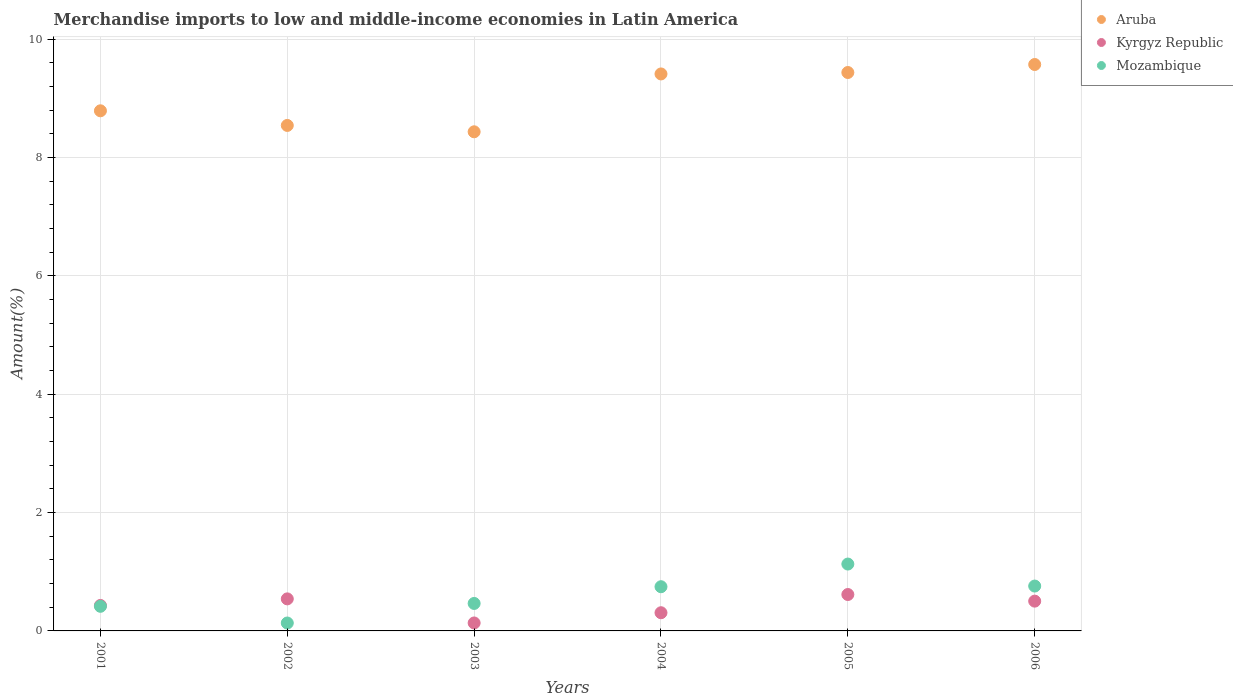How many different coloured dotlines are there?
Offer a terse response. 3. Is the number of dotlines equal to the number of legend labels?
Keep it short and to the point. Yes. What is the percentage of amount earned from merchandise imports in Kyrgyz Republic in 2004?
Your answer should be very brief. 0.31. Across all years, what is the maximum percentage of amount earned from merchandise imports in Aruba?
Offer a very short reply. 9.57. Across all years, what is the minimum percentage of amount earned from merchandise imports in Kyrgyz Republic?
Provide a short and direct response. 0.13. In which year was the percentage of amount earned from merchandise imports in Kyrgyz Republic maximum?
Your response must be concise. 2005. What is the total percentage of amount earned from merchandise imports in Kyrgyz Republic in the graph?
Keep it short and to the point. 2.53. What is the difference between the percentage of amount earned from merchandise imports in Kyrgyz Republic in 2002 and that in 2006?
Keep it short and to the point. 0.04. What is the difference between the percentage of amount earned from merchandise imports in Mozambique in 2003 and the percentage of amount earned from merchandise imports in Aruba in 2005?
Your response must be concise. -8.97. What is the average percentage of amount earned from merchandise imports in Kyrgyz Republic per year?
Your answer should be very brief. 0.42. In the year 2004, what is the difference between the percentage of amount earned from merchandise imports in Mozambique and percentage of amount earned from merchandise imports in Aruba?
Your answer should be very brief. -8.67. What is the ratio of the percentage of amount earned from merchandise imports in Aruba in 2005 to that in 2006?
Your answer should be compact. 0.99. Is the percentage of amount earned from merchandise imports in Kyrgyz Republic in 2001 less than that in 2006?
Ensure brevity in your answer.  Yes. Is the difference between the percentage of amount earned from merchandise imports in Mozambique in 2004 and 2006 greater than the difference between the percentage of amount earned from merchandise imports in Aruba in 2004 and 2006?
Your answer should be very brief. Yes. What is the difference between the highest and the second highest percentage of amount earned from merchandise imports in Mozambique?
Offer a very short reply. 0.37. What is the difference between the highest and the lowest percentage of amount earned from merchandise imports in Mozambique?
Provide a short and direct response. 1. In how many years, is the percentage of amount earned from merchandise imports in Mozambique greater than the average percentage of amount earned from merchandise imports in Mozambique taken over all years?
Give a very brief answer. 3. Is the sum of the percentage of amount earned from merchandise imports in Mozambique in 2001 and 2002 greater than the maximum percentage of amount earned from merchandise imports in Aruba across all years?
Provide a short and direct response. No. Is it the case that in every year, the sum of the percentage of amount earned from merchandise imports in Kyrgyz Republic and percentage of amount earned from merchandise imports in Mozambique  is greater than the percentage of amount earned from merchandise imports in Aruba?
Your answer should be compact. No. Does the percentage of amount earned from merchandise imports in Aruba monotonically increase over the years?
Provide a succinct answer. No. Is the percentage of amount earned from merchandise imports in Kyrgyz Republic strictly less than the percentage of amount earned from merchandise imports in Aruba over the years?
Ensure brevity in your answer.  Yes. How many years are there in the graph?
Make the answer very short. 6. Are the values on the major ticks of Y-axis written in scientific E-notation?
Your answer should be very brief. No. Does the graph contain any zero values?
Provide a succinct answer. No. Does the graph contain grids?
Your answer should be very brief. Yes. Where does the legend appear in the graph?
Your response must be concise. Top right. How are the legend labels stacked?
Offer a very short reply. Vertical. What is the title of the graph?
Offer a very short reply. Merchandise imports to low and middle-income economies in Latin America. What is the label or title of the Y-axis?
Provide a short and direct response. Amount(%). What is the Amount(%) in Aruba in 2001?
Provide a short and direct response. 8.79. What is the Amount(%) of Kyrgyz Republic in 2001?
Give a very brief answer. 0.43. What is the Amount(%) of Mozambique in 2001?
Your response must be concise. 0.42. What is the Amount(%) in Aruba in 2002?
Provide a succinct answer. 8.54. What is the Amount(%) of Kyrgyz Republic in 2002?
Ensure brevity in your answer.  0.54. What is the Amount(%) in Mozambique in 2002?
Provide a short and direct response. 0.13. What is the Amount(%) of Aruba in 2003?
Your answer should be compact. 8.44. What is the Amount(%) of Kyrgyz Republic in 2003?
Offer a terse response. 0.13. What is the Amount(%) of Mozambique in 2003?
Offer a very short reply. 0.46. What is the Amount(%) in Aruba in 2004?
Make the answer very short. 9.41. What is the Amount(%) in Kyrgyz Republic in 2004?
Make the answer very short. 0.31. What is the Amount(%) of Mozambique in 2004?
Provide a short and direct response. 0.75. What is the Amount(%) in Aruba in 2005?
Offer a terse response. 9.44. What is the Amount(%) in Kyrgyz Republic in 2005?
Give a very brief answer. 0.62. What is the Amount(%) of Mozambique in 2005?
Offer a very short reply. 1.13. What is the Amount(%) of Aruba in 2006?
Offer a terse response. 9.57. What is the Amount(%) of Kyrgyz Republic in 2006?
Provide a short and direct response. 0.5. What is the Amount(%) in Mozambique in 2006?
Make the answer very short. 0.76. Across all years, what is the maximum Amount(%) in Aruba?
Give a very brief answer. 9.57. Across all years, what is the maximum Amount(%) in Kyrgyz Republic?
Keep it short and to the point. 0.62. Across all years, what is the maximum Amount(%) of Mozambique?
Provide a succinct answer. 1.13. Across all years, what is the minimum Amount(%) in Aruba?
Keep it short and to the point. 8.44. Across all years, what is the minimum Amount(%) of Kyrgyz Republic?
Give a very brief answer. 0.13. Across all years, what is the minimum Amount(%) of Mozambique?
Your answer should be compact. 0.13. What is the total Amount(%) of Aruba in the graph?
Offer a terse response. 54.19. What is the total Amount(%) in Kyrgyz Republic in the graph?
Offer a terse response. 2.53. What is the total Amount(%) of Mozambique in the graph?
Keep it short and to the point. 3.65. What is the difference between the Amount(%) in Aruba in 2001 and that in 2002?
Offer a very short reply. 0.25. What is the difference between the Amount(%) in Kyrgyz Republic in 2001 and that in 2002?
Offer a very short reply. -0.11. What is the difference between the Amount(%) in Mozambique in 2001 and that in 2002?
Ensure brevity in your answer.  0.28. What is the difference between the Amount(%) of Aruba in 2001 and that in 2003?
Offer a terse response. 0.35. What is the difference between the Amount(%) of Kyrgyz Republic in 2001 and that in 2003?
Your answer should be compact. 0.3. What is the difference between the Amount(%) in Mozambique in 2001 and that in 2003?
Your answer should be very brief. -0.05. What is the difference between the Amount(%) in Aruba in 2001 and that in 2004?
Keep it short and to the point. -0.62. What is the difference between the Amount(%) of Kyrgyz Republic in 2001 and that in 2004?
Offer a very short reply. 0.12. What is the difference between the Amount(%) in Mozambique in 2001 and that in 2004?
Make the answer very short. -0.33. What is the difference between the Amount(%) in Aruba in 2001 and that in 2005?
Provide a succinct answer. -0.65. What is the difference between the Amount(%) in Kyrgyz Republic in 2001 and that in 2005?
Your answer should be very brief. -0.18. What is the difference between the Amount(%) in Mozambique in 2001 and that in 2005?
Offer a very short reply. -0.71. What is the difference between the Amount(%) in Aruba in 2001 and that in 2006?
Your answer should be compact. -0.78. What is the difference between the Amount(%) in Kyrgyz Republic in 2001 and that in 2006?
Provide a short and direct response. -0.07. What is the difference between the Amount(%) of Mozambique in 2001 and that in 2006?
Your response must be concise. -0.34. What is the difference between the Amount(%) in Aruba in 2002 and that in 2003?
Give a very brief answer. 0.11. What is the difference between the Amount(%) in Kyrgyz Republic in 2002 and that in 2003?
Your answer should be compact. 0.41. What is the difference between the Amount(%) in Mozambique in 2002 and that in 2003?
Provide a succinct answer. -0.33. What is the difference between the Amount(%) of Aruba in 2002 and that in 2004?
Provide a succinct answer. -0.87. What is the difference between the Amount(%) of Kyrgyz Republic in 2002 and that in 2004?
Ensure brevity in your answer.  0.23. What is the difference between the Amount(%) of Mozambique in 2002 and that in 2004?
Keep it short and to the point. -0.61. What is the difference between the Amount(%) in Aruba in 2002 and that in 2005?
Your response must be concise. -0.89. What is the difference between the Amount(%) of Kyrgyz Republic in 2002 and that in 2005?
Provide a short and direct response. -0.07. What is the difference between the Amount(%) in Mozambique in 2002 and that in 2005?
Give a very brief answer. -1. What is the difference between the Amount(%) of Aruba in 2002 and that in 2006?
Your answer should be compact. -1.03. What is the difference between the Amount(%) in Kyrgyz Republic in 2002 and that in 2006?
Give a very brief answer. 0.04. What is the difference between the Amount(%) in Mozambique in 2002 and that in 2006?
Offer a very short reply. -0.62. What is the difference between the Amount(%) of Aruba in 2003 and that in 2004?
Your response must be concise. -0.98. What is the difference between the Amount(%) in Kyrgyz Republic in 2003 and that in 2004?
Give a very brief answer. -0.17. What is the difference between the Amount(%) in Mozambique in 2003 and that in 2004?
Provide a short and direct response. -0.28. What is the difference between the Amount(%) in Aruba in 2003 and that in 2005?
Your response must be concise. -1. What is the difference between the Amount(%) in Kyrgyz Republic in 2003 and that in 2005?
Offer a very short reply. -0.48. What is the difference between the Amount(%) in Mozambique in 2003 and that in 2005?
Your response must be concise. -0.67. What is the difference between the Amount(%) of Aruba in 2003 and that in 2006?
Offer a very short reply. -1.14. What is the difference between the Amount(%) of Kyrgyz Republic in 2003 and that in 2006?
Make the answer very short. -0.37. What is the difference between the Amount(%) of Mozambique in 2003 and that in 2006?
Your answer should be very brief. -0.29. What is the difference between the Amount(%) of Aruba in 2004 and that in 2005?
Your answer should be compact. -0.02. What is the difference between the Amount(%) in Kyrgyz Republic in 2004 and that in 2005?
Offer a terse response. -0.31. What is the difference between the Amount(%) in Mozambique in 2004 and that in 2005?
Ensure brevity in your answer.  -0.38. What is the difference between the Amount(%) of Aruba in 2004 and that in 2006?
Offer a terse response. -0.16. What is the difference between the Amount(%) in Kyrgyz Republic in 2004 and that in 2006?
Your answer should be compact. -0.2. What is the difference between the Amount(%) of Mozambique in 2004 and that in 2006?
Keep it short and to the point. -0.01. What is the difference between the Amount(%) of Aruba in 2005 and that in 2006?
Keep it short and to the point. -0.14. What is the difference between the Amount(%) in Kyrgyz Republic in 2005 and that in 2006?
Give a very brief answer. 0.11. What is the difference between the Amount(%) in Mozambique in 2005 and that in 2006?
Ensure brevity in your answer.  0.37. What is the difference between the Amount(%) in Aruba in 2001 and the Amount(%) in Kyrgyz Republic in 2002?
Offer a very short reply. 8.25. What is the difference between the Amount(%) in Aruba in 2001 and the Amount(%) in Mozambique in 2002?
Your answer should be very brief. 8.66. What is the difference between the Amount(%) of Kyrgyz Republic in 2001 and the Amount(%) of Mozambique in 2002?
Your answer should be very brief. 0.3. What is the difference between the Amount(%) in Aruba in 2001 and the Amount(%) in Kyrgyz Republic in 2003?
Give a very brief answer. 8.66. What is the difference between the Amount(%) in Aruba in 2001 and the Amount(%) in Mozambique in 2003?
Keep it short and to the point. 8.33. What is the difference between the Amount(%) of Kyrgyz Republic in 2001 and the Amount(%) of Mozambique in 2003?
Provide a succinct answer. -0.03. What is the difference between the Amount(%) of Aruba in 2001 and the Amount(%) of Kyrgyz Republic in 2004?
Your answer should be very brief. 8.48. What is the difference between the Amount(%) of Aruba in 2001 and the Amount(%) of Mozambique in 2004?
Your answer should be very brief. 8.04. What is the difference between the Amount(%) in Kyrgyz Republic in 2001 and the Amount(%) in Mozambique in 2004?
Offer a terse response. -0.32. What is the difference between the Amount(%) in Aruba in 2001 and the Amount(%) in Kyrgyz Republic in 2005?
Your answer should be very brief. 8.18. What is the difference between the Amount(%) of Aruba in 2001 and the Amount(%) of Mozambique in 2005?
Offer a terse response. 7.66. What is the difference between the Amount(%) of Kyrgyz Republic in 2001 and the Amount(%) of Mozambique in 2005?
Ensure brevity in your answer.  -0.7. What is the difference between the Amount(%) of Aruba in 2001 and the Amount(%) of Kyrgyz Republic in 2006?
Give a very brief answer. 8.29. What is the difference between the Amount(%) in Aruba in 2001 and the Amount(%) in Mozambique in 2006?
Give a very brief answer. 8.03. What is the difference between the Amount(%) of Kyrgyz Republic in 2001 and the Amount(%) of Mozambique in 2006?
Ensure brevity in your answer.  -0.33. What is the difference between the Amount(%) in Aruba in 2002 and the Amount(%) in Kyrgyz Republic in 2003?
Keep it short and to the point. 8.41. What is the difference between the Amount(%) in Aruba in 2002 and the Amount(%) in Mozambique in 2003?
Your answer should be very brief. 8.08. What is the difference between the Amount(%) of Kyrgyz Republic in 2002 and the Amount(%) of Mozambique in 2003?
Your response must be concise. 0.08. What is the difference between the Amount(%) in Aruba in 2002 and the Amount(%) in Kyrgyz Republic in 2004?
Make the answer very short. 8.24. What is the difference between the Amount(%) of Aruba in 2002 and the Amount(%) of Mozambique in 2004?
Keep it short and to the point. 7.8. What is the difference between the Amount(%) of Kyrgyz Republic in 2002 and the Amount(%) of Mozambique in 2004?
Ensure brevity in your answer.  -0.21. What is the difference between the Amount(%) of Aruba in 2002 and the Amount(%) of Kyrgyz Republic in 2005?
Your response must be concise. 7.93. What is the difference between the Amount(%) in Aruba in 2002 and the Amount(%) in Mozambique in 2005?
Ensure brevity in your answer.  7.41. What is the difference between the Amount(%) in Kyrgyz Republic in 2002 and the Amount(%) in Mozambique in 2005?
Give a very brief answer. -0.59. What is the difference between the Amount(%) in Aruba in 2002 and the Amount(%) in Kyrgyz Republic in 2006?
Your response must be concise. 8.04. What is the difference between the Amount(%) of Aruba in 2002 and the Amount(%) of Mozambique in 2006?
Your answer should be very brief. 7.78. What is the difference between the Amount(%) of Kyrgyz Republic in 2002 and the Amount(%) of Mozambique in 2006?
Offer a terse response. -0.22. What is the difference between the Amount(%) in Aruba in 2003 and the Amount(%) in Kyrgyz Republic in 2004?
Your answer should be very brief. 8.13. What is the difference between the Amount(%) in Aruba in 2003 and the Amount(%) in Mozambique in 2004?
Make the answer very short. 7.69. What is the difference between the Amount(%) in Kyrgyz Republic in 2003 and the Amount(%) in Mozambique in 2004?
Your answer should be very brief. -0.61. What is the difference between the Amount(%) of Aruba in 2003 and the Amount(%) of Kyrgyz Republic in 2005?
Offer a terse response. 7.82. What is the difference between the Amount(%) of Aruba in 2003 and the Amount(%) of Mozambique in 2005?
Provide a succinct answer. 7.31. What is the difference between the Amount(%) of Kyrgyz Republic in 2003 and the Amount(%) of Mozambique in 2005?
Ensure brevity in your answer.  -1. What is the difference between the Amount(%) of Aruba in 2003 and the Amount(%) of Kyrgyz Republic in 2006?
Provide a short and direct response. 7.93. What is the difference between the Amount(%) of Aruba in 2003 and the Amount(%) of Mozambique in 2006?
Provide a short and direct response. 7.68. What is the difference between the Amount(%) of Kyrgyz Republic in 2003 and the Amount(%) of Mozambique in 2006?
Offer a very short reply. -0.62. What is the difference between the Amount(%) of Aruba in 2004 and the Amount(%) of Kyrgyz Republic in 2005?
Ensure brevity in your answer.  8.8. What is the difference between the Amount(%) in Aruba in 2004 and the Amount(%) in Mozambique in 2005?
Your response must be concise. 8.28. What is the difference between the Amount(%) of Kyrgyz Republic in 2004 and the Amount(%) of Mozambique in 2005?
Provide a short and direct response. -0.82. What is the difference between the Amount(%) in Aruba in 2004 and the Amount(%) in Kyrgyz Republic in 2006?
Ensure brevity in your answer.  8.91. What is the difference between the Amount(%) in Aruba in 2004 and the Amount(%) in Mozambique in 2006?
Your answer should be compact. 8.66. What is the difference between the Amount(%) of Kyrgyz Republic in 2004 and the Amount(%) of Mozambique in 2006?
Ensure brevity in your answer.  -0.45. What is the difference between the Amount(%) of Aruba in 2005 and the Amount(%) of Kyrgyz Republic in 2006?
Ensure brevity in your answer.  8.93. What is the difference between the Amount(%) in Aruba in 2005 and the Amount(%) in Mozambique in 2006?
Keep it short and to the point. 8.68. What is the difference between the Amount(%) of Kyrgyz Republic in 2005 and the Amount(%) of Mozambique in 2006?
Your answer should be very brief. -0.14. What is the average Amount(%) of Aruba per year?
Your answer should be very brief. 9.03. What is the average Amount(%) in Kyrgyz Republic per year?
Offer a very short reply. 0.42. What is the average Amount(%) in Mozambique per year?
Make the answer very short. 0.61. In the year 2001, what is the difference between the Amount(%) of Aruba and Amount(%) of Kyrgyz Republic?
Offer a terse response. 8.36. In the year 2001, what is the difference between the Amount(%) in Aruba and Amount(%) in Mozambique?
Ensure brevity in your answer.  8.37. In the year 2001, what is the difference between the Amount(%) in Kyrgyz Republic and Amount(%) in Mozambique?
Your response must be concise. 0.01. In the year 2002, what is the difference between the Amount(%) of Aruba and Amount(%) of Kyrgyz Republic?
Make the answer very short. 8. In the year 2002, what is the difference between the Amount(%) in Aruba and Amount(%) in Mozambique?
Ensure brevity in your answer.  8.41. In the year 2002, what is the difference between the Amount(%) of Kyrgyz Republic and Amount(%) of Mozambique?
Offer a terse response. 0.41. In the year 2003, what is the difference between the Amount(%) in Aruba and Amount(%) in Kyrgyz Republic?
Provide a short and direct response. 8.3. In the year 2003, what is the difference between the Amount(%) of Aruba and Amount(%) of Mozambique?
Your response must be concise. 7.97. In the year 2003, what is the difference between the Amount(%) of Kyrgyz Republic and Amount(%) of Mozambique?
Provide a succinct answer. -0.33. In the year 2004, what is the difference between the Amount(%) in Aruba and Amount(%) in Kyrgyz Republic?
Provide a succinct answer. 9.11. In the year 2004, what is the difference between the Amount(%) of Aruba and Amount(%) of Mozambique?
Your response must be concise. 8.67. In the year 2004, what is the difference between the Amount(%) of Kyrgyz Republic and Amount(%) of Mozambique?
Provide a succinct answer. -0.44. In the year 2005, what is the difference between the Amount(%) of Aruba and Amount(%) of Kyrgyz Republic?
Ensure brevity in your answer.  8.82. In the year 2005, what is the difference between the Amount(%) in Aruba and Amount(%) in Mozambique?
Keep it short and to the point. 8.31. In the year 2005, what is the difference between the Amount(%) in Kyrgyz Republic and Amount(%) in Mozambique?
Offer a very short reply. -0.51. In the year 2006, what is the difference between the Amount(%) in Aruba and Amount(%) in Kyrgyz Republic?
Offer a very short reply. 9.07. In the year 2006, what is the difference between the Amount(%) of Aruba and Amount(%) of Mozambique?
Ensure brevity in your answer.  8.81. In the year 2006, what is the difference between the Amount(%) in Kyrgyz Republic and Amount(%) in Mozambique?
Make the answer very short. -0.26. What is the ratio of the Amount(%) of Aruba in 2001 to that in 2002?
Your response must be concise. 1.03. What is the ratio of the Amount(%) in Kyrgyz Republic in 2001 to that in 2002?
Your answer should be very brief. 0.79. What is the ratio of the Amount(%) of Mozambique in 2001 to that in 2002?
Ensure brevity in your answer.  3.11. What is the ratio of the Amount(%) in Aruba in 2001 to that in 2003?
Give a very brief answer. 1.04. What is the ratio of the Amount(%) of Kyrgyz Republic in 2001 to that in 2003?
Offer a terse response. 3.2. What is the ratio of the Amount(%) in Mozambique in 2001 to that in 2003?
Offer a terse response. 0.9. What is the ratio of the Amount(%) in Aruba in 2001 to that in 2004?
Make the answer very short. 0.93. What is the ratio of the Amount(%) in Kyrgyz Republic in 2001 to that in 2004?
Provide a succinct answer. 1.4. What is the ratio of the Amount(%) of Mozambique in 2001 to that in 2004?
Keep it short and to the point. 0.56. What is the ratio of the Amount(%) of Aruba in 2001 to that in 2005?
Offer a terse response. 0.93. What is the ratio of the Amount(%) in Kyrgyz Republic in 2001 to that in 2005?
Your response must be concise. 0.7. What is the ratio of the Amount(%) in Mozambique in 2001 to that in 2005?
Your answer should be very brief. 0.37. What is the ratio of the Amount(%) in Aruba in 2001 to that in 2006?
Keep it short and to the point. 0.92. What is the ratio of the Amount(%) of Kyrgyz Republic in 2001 to that in 2006?
Your answer should be compact. 0.86. What is the ratio of the Amount(%) of Mozambique in 2001 to that in 2006?
Your response must be concise. 0.55. What is the ratio of the Amount(%) in Aruba in 2002 to that in 2003?
Provide a short and direct response. 1.01. What is the ratio of the Amount(%) in Kyrgyz Republic in 2002 to that in 2003?
Make the answer very short. 4.03. What is the ratio of the Amount(%) in Mozambique in 2002 to that in 2003?
Provide a succinct answer. 0.29. What is the ratio of the Amount(%) of Aruba in 2002 to that in 2004?
Provide a succinct answer. 0.91. What is the ratio of the Amount(%) of Kyrgyz Republic in 2002 to that in 2004?
Give a very brief answer. 1.76. What is the ratio of the Amount(%) of Mozambique in 2002 to that in 2004?
Offer a terse response. 0.18. What is the ratio of the Amount(%) of Aruba in 2002 to that in 2005?
Your answer should be compact. 0.91. What is the ratio of the Amount(%) of Kyrgyz Republic in 2002 to that in 2005?
Keep it short and to the point. 0.88. What is the ratio of the Amount(%) in Mozambique in 2002 to that in 2005?
Offer a very short reply. 0.12. What is the ratio of the Amount(%) of Aruba in 2002 to that in 2006?
Offer a very short reply. 0.89. What is the ratio of the Amount(%) of Kyrgyz Republic in 2002 to that in 2006?
Make the answer very short. 1.08. What is the ratio of the Amount(%) in Mozambique in 2002 to that in 2006?
Make the answer very short. 0.18. What is the ratio of the Amount(%) in Aruba in 2003 to that in 2004?
Offer a very short reply. 0.9. What is the ratio of the Amount(%) in Kyrgyz Republic in 2003 to that in 2004?
Make the answer very short. 0.44. What is the ratio of the Amount(%) of Mozambique in 2003 to that in 2004?
Give a very brief answer. 0.62. What is the ratio of the Amount(%) in Aruba in 2003 to that in 2005?
Your response must be concise. 0.89. What is the ratio of the Amount(%) in Kyrgyz Republic in 2003 to that in 2005?
Your answer should be compact. 0.22. What is the ratio of the Amount(%) in Mozambique in 2003 to that in 2005?
Offer a terse response. 0.41. What is the ratio of the Amount(%) of Aruba in 2003 to that in 2006?
Your answer should be very brief. 0.88. What is the ratio of the Amount(%) of Kyrgyz Republic in 2003 to that in 2006?
Your answer should be compact. 0.27. What is the ratio of the Amount(%) of Mozambique in 2003 to that in 2006?
Ensure brevity in your answer.  0.61. What is the ratio of the Amount(%) of Kyrgyz Republic in 2004 to that in 2005?
Keep it short and to the point. 0.5. What is the ratio of the Amount(%) of Mozambique in 2004 to that in 2005?
Offer a very short reply. 0.66. What is the ratio of the Amount(%) in Aruba in 2004 to that in 2006?
Ensure brevity in your answer.  0.98. What is the ratio of the Amount(%) in Kyrgyz Republic in 2004 to that in 2006?
Provide a succinct answer. 0.61. What is the ratio of the Amount(%) in Mozambique in 2004 to that in 2006?
Make the answer very short. 0.98. What is the ratio of the Amount(%) in Aruba in 2005 to that in 2006?
Provide a succinct answer. 0.99. What is the ratio of the Amount(%) of Kyrgyz Republic in 2005 to that in 2006?
Your answer should be compact. 1.22. What is the ratio of the Amount(%) in Mozambique in 2005 to that in 2006?
Provide a short and direct response. 1.49. What is the difference between the highest and the second highest Amount(%) of Aruba?
Ensure brevity in your answer.  0.14. What is the difference between the highest and the second highest Amount(%) of Kyrgyz Republic?
Keep it short and to the point. 0.07. What is the difference between the highest and the second highest Amount(%) in Mozambique?
Your answer should be compact. 0.37. What is the difference between the highest and the lowest Amount(%) in Aruba?
Keep it short and to the point. 1.14. What is the difference between the highest and the lowest Amount(%) of Kyrgyz Republic?
Provide a succinct answer. 0.48. What is the difference between the highest and the lowest Amount(%) in Mozambique?
Your response must be concise. 1. 